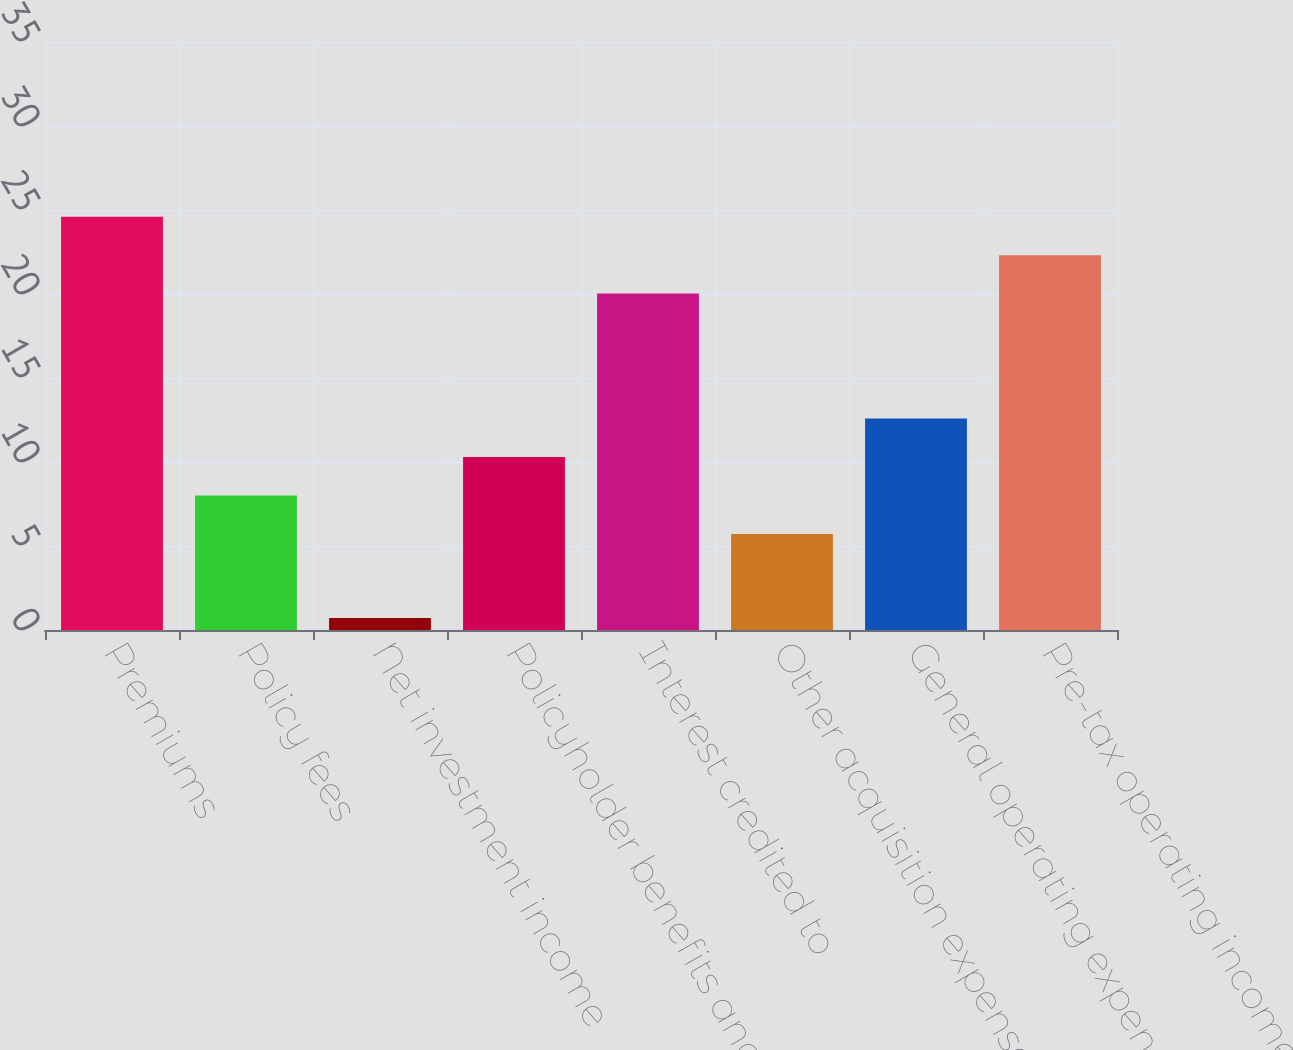Convert chart. <chart><loc_0><loc_0><loc_500><loc_500><bar_chart><fcel>Premiums<fcel>Policy fees<fcel>Net investment income<fcel>Policyholder benefits and<fcel>Interest credited to<fcel>Other acquisition expenses<fcel>General operating expenses<fcel>Pre-tax operating income<nl><fcel>34.4<fcel>11.2<fcel>1<fcel>14.4<fcel>28<fcel>8<fcel>17.6<fcel>31.2<nl></chart> 